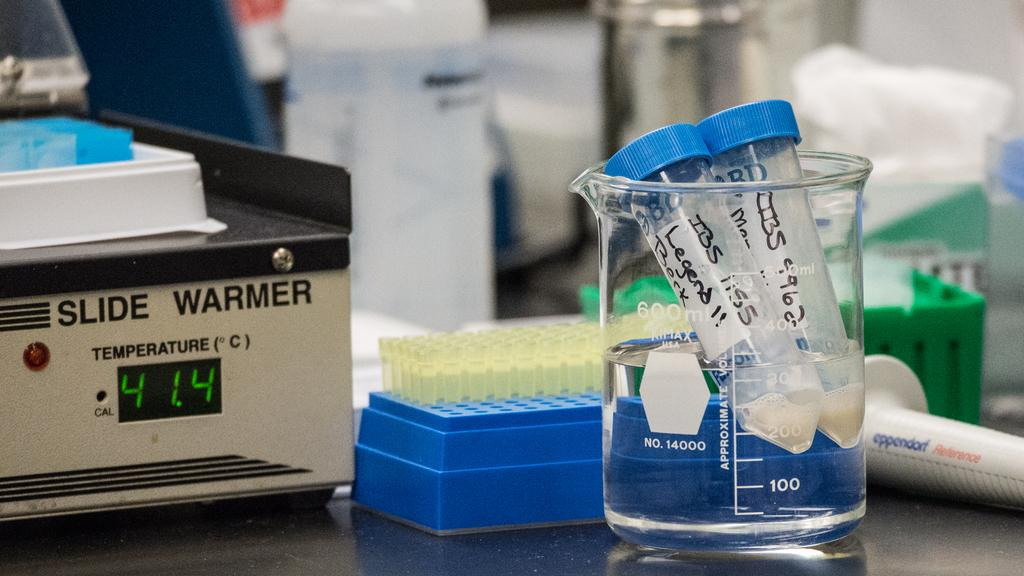<image>
Provide a brief description of the given image. Beaker with tubes in it titled Legend and exclamation marks. 